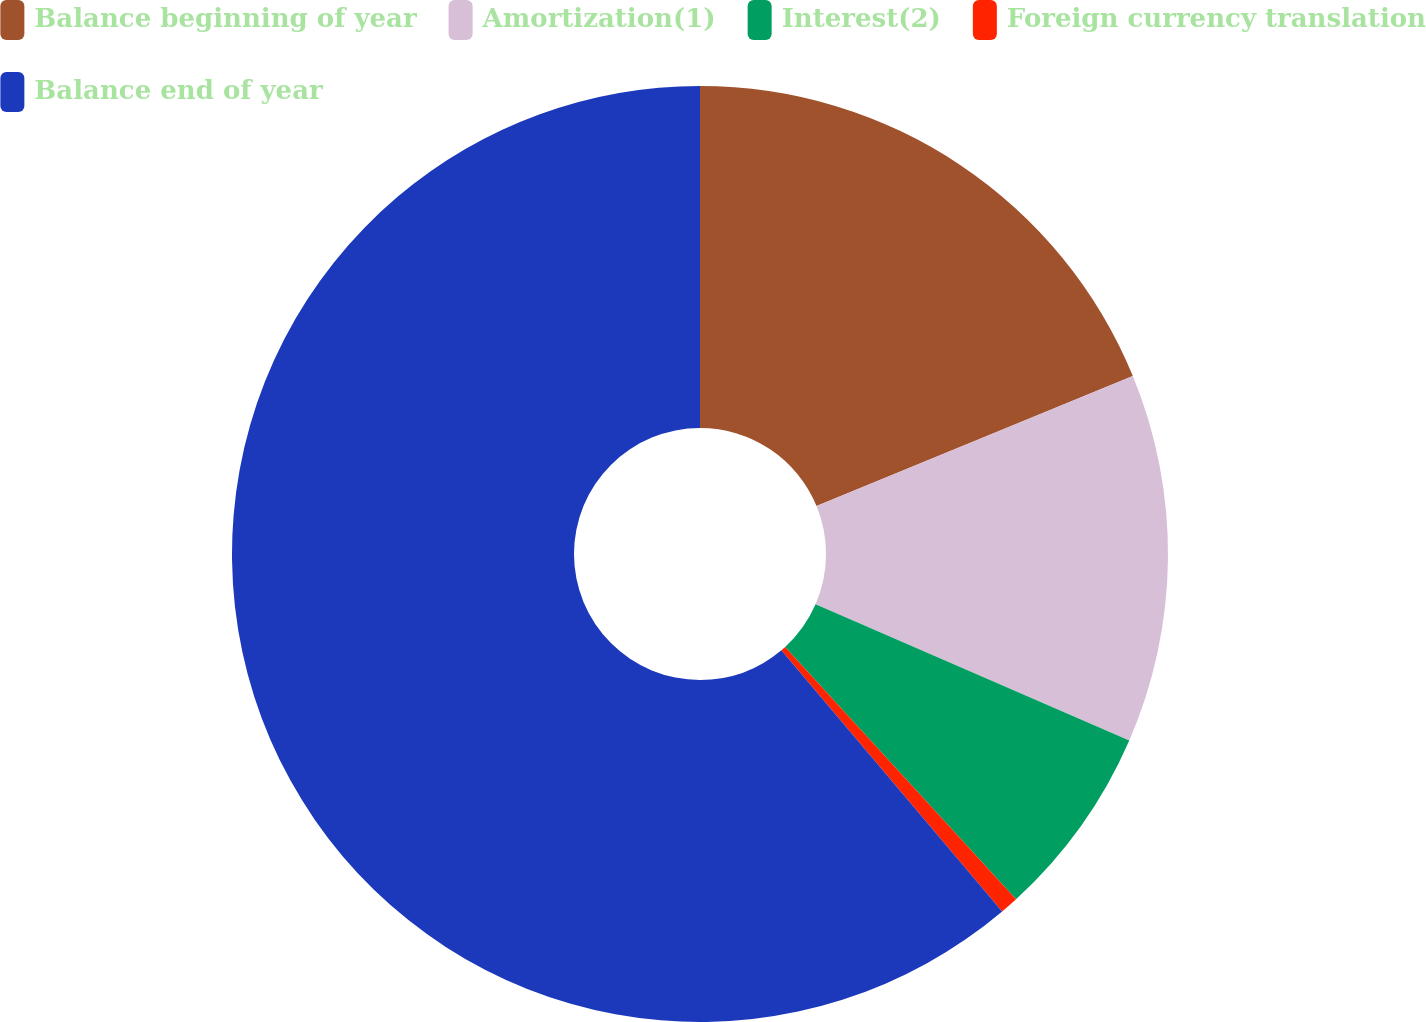Convert chart. <chart><loc_0><loc_0><loc_500><loc_500><pie_chart><fcel>Balance beginning of year<fcel>Amortization(1)<fcel>Interest(2)<fcel>Foreign currency translation<fcel>Balance end of year<nl><fcel>18.79%<fcel>12.73%<fcel>6.68%<fcel>0.63%<fcel>61.17%<nl></chart> 